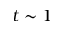Convert formula to latex. <formula><loc_0><loc_0><loc_500><loc_500>t \sim 1</formula> 